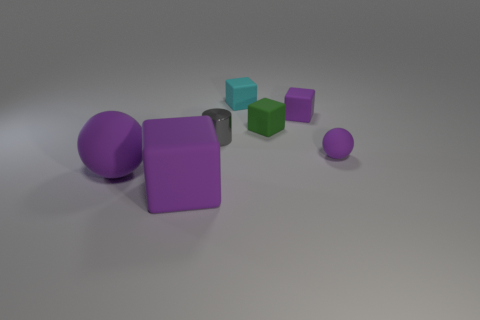What is the shape of the other cyan thing that is the same size as the shiny thing?
Offer a terse response. Cube. Are there any other things that have the same size as the shiny cylinder?
Your response must be concise. Yes. Does the green cube on the left side of the small matte ball have the same size as the purple rubber cube in front of the tiny green matte block?
Your answer should be compact. No. What is the size of the purple rubber cube that is behind the large block?
Offer a very short reply. Small. There is a big sphere that is the same color as the small matte sphere; what is its material?
Provide a short and direct response. Rubber. What color is the metallic cylinder that is the same size as the green matte object?
Provide a short and direct response. Gray. Do the cyan cube and the metal object have the same size?
Make the answer very short. Yes. What size is the rubber object that is on the right side of the small cyan object and to the left of the tiny purple matte block?
Provide a short and direct response. Small. What number of matte objects are either cyan blocks or large purple balls?
Provide a succinct answer. 2. Are there more small balls that are left of the large purple ball than blue cubes?
Provide a succinct answer. No. 